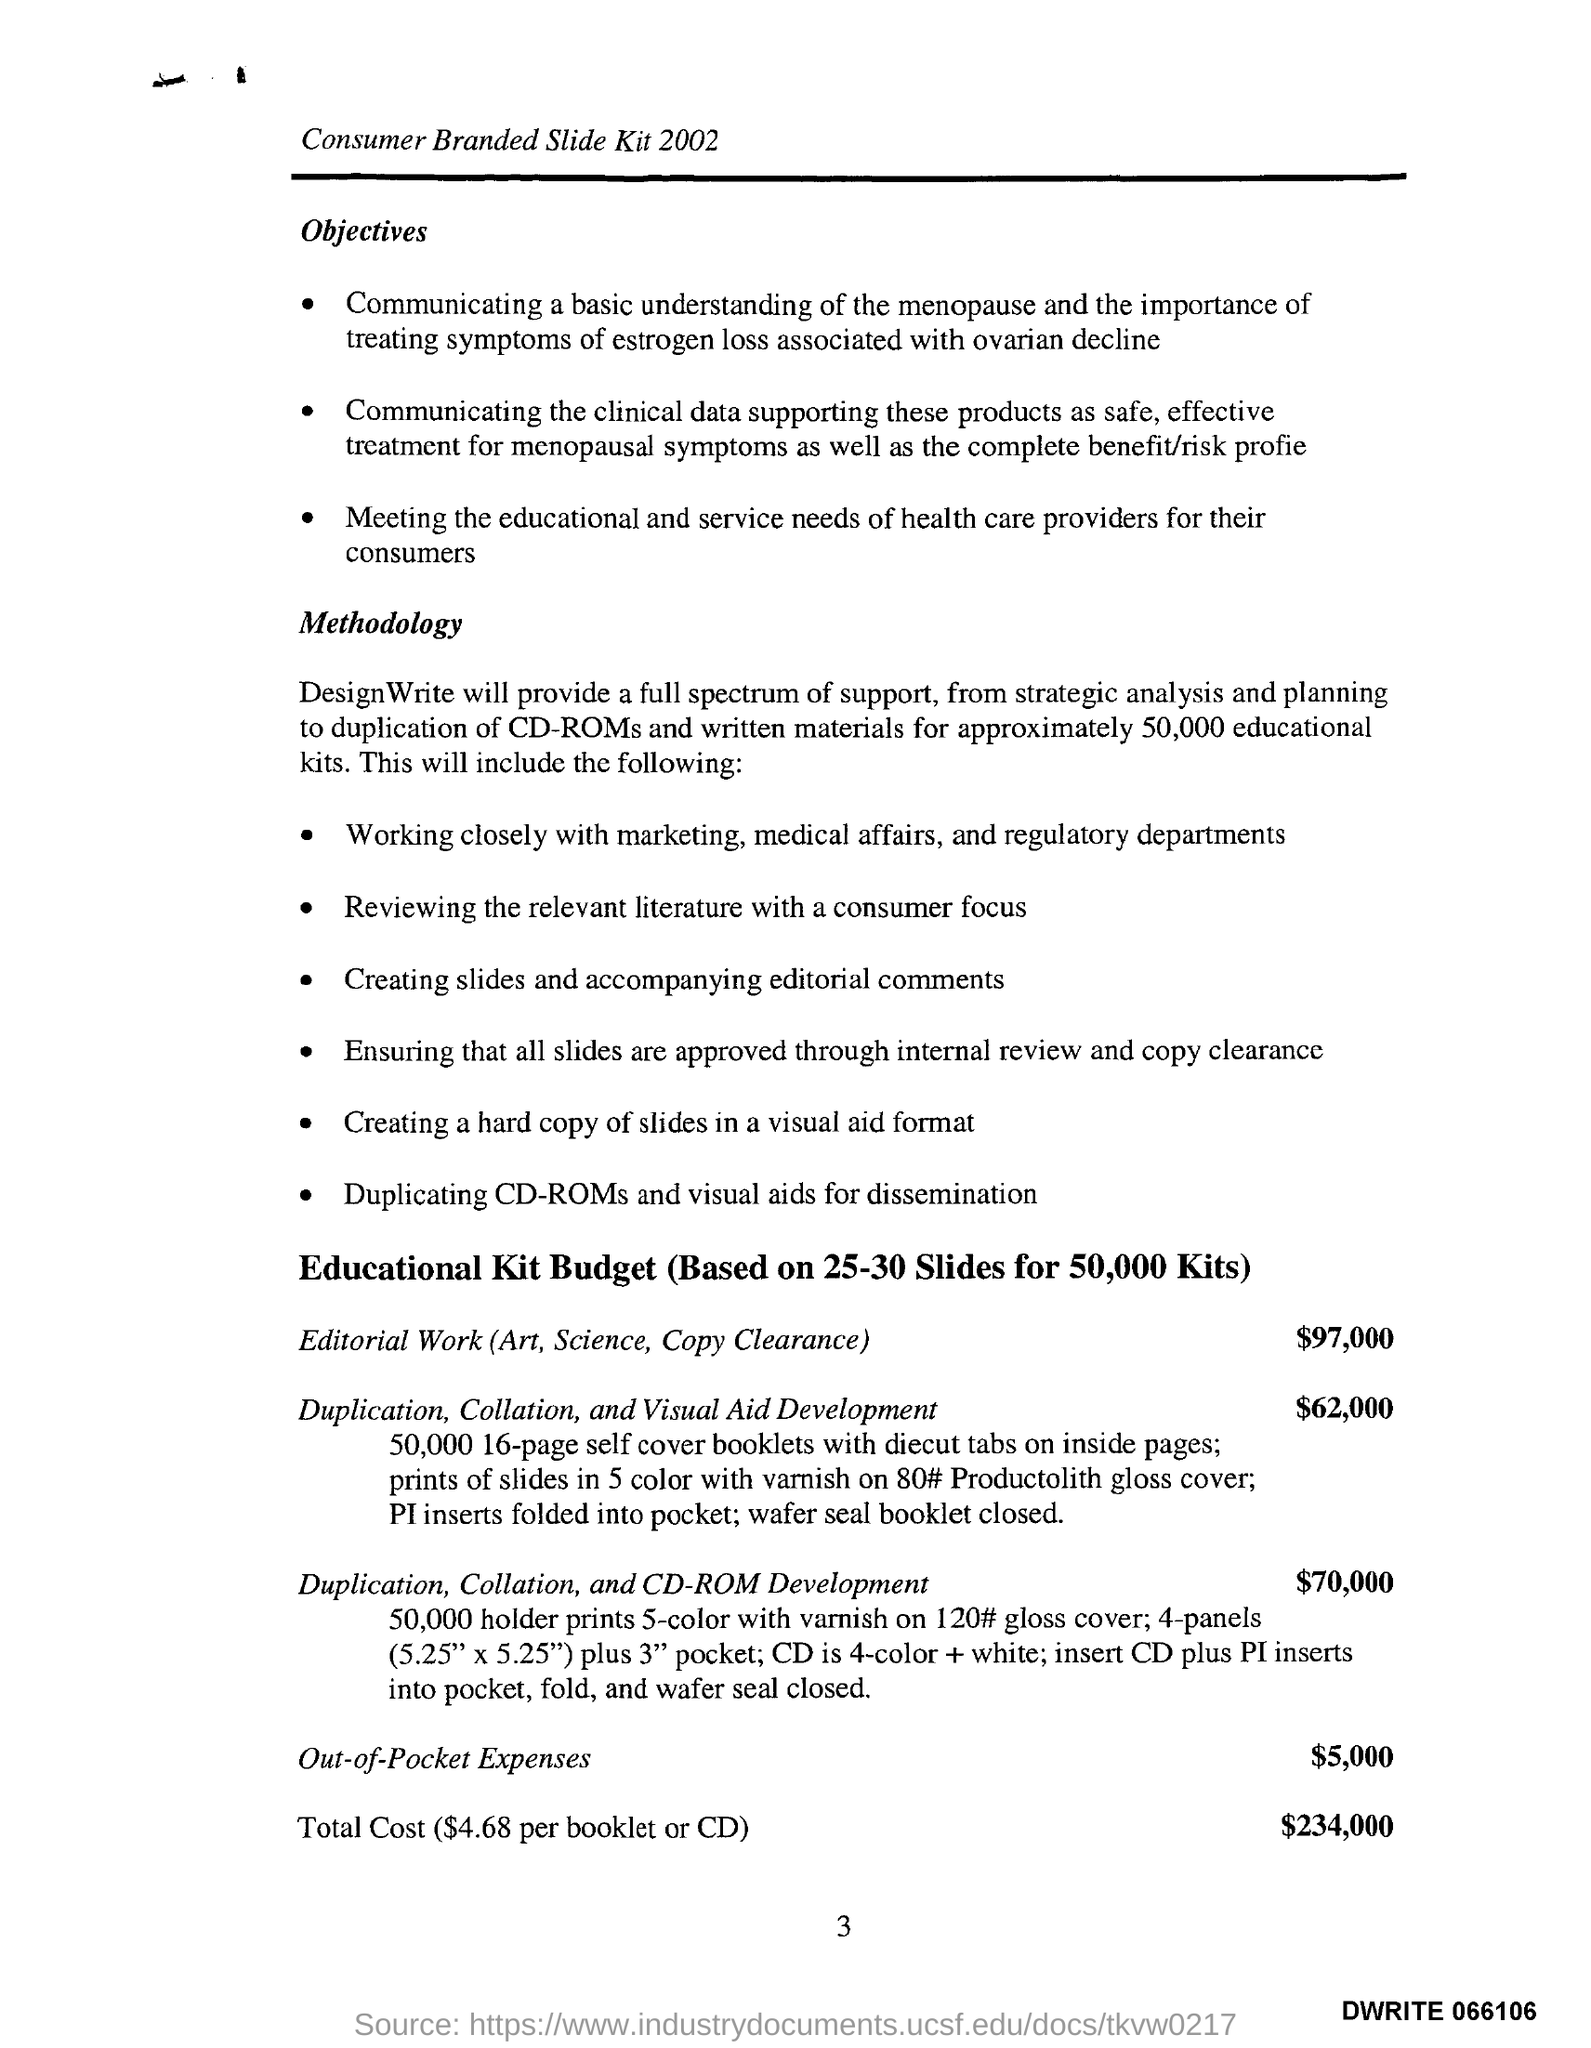Mention a couple of crucial points in this snapshot. The total cost is $234,000. The page number is 3. The budget for editorial work is $97,000. The out-of-pocket expense is $5,000. 